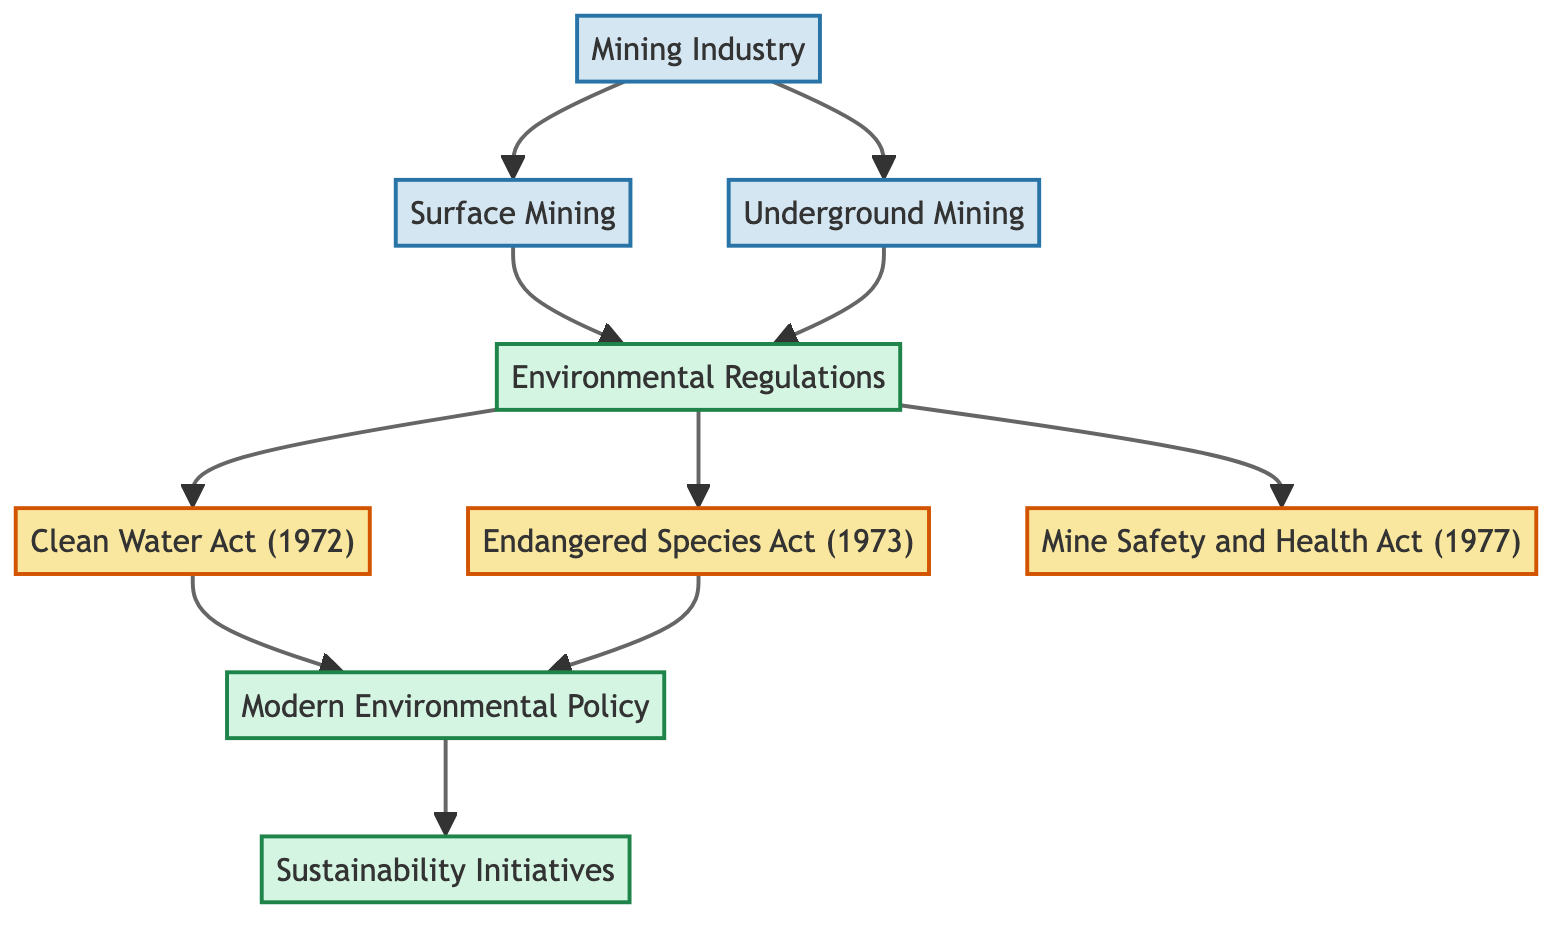What is the total number of nodes in the diagram? The diagram consists of nodes representing key concepts related to mining and environmental policies. Counting them, we have 9 distinct nodes: Mining Industry, Environmental Regulations, Surface Mining, Underground Mining, Clean Water Act, Endangered Species Act, Mining Safety and Health Act, Modern Environmental Policy, and Sustainability Initiatives.
Answer: 9 Which act was established in 1972? According to the diagram, the Clean Water Act is shown to have a direct connection to the Environmental Regulations node and was established in 1972.
Answer: Clean Water Act What connects Surface Mining to Environmental Regulations? The diagram indicates a direct arrow (or edge) from Surface Mining to Environmental Regulations, showing that Surface Mining practices influence or are governed by these regulations.
Answer: Environmental Regulations How many significant acts are directly linked to Environmental Regulations? From the diagram, there are three significant acts connected directly to Environmental Regulations: Clean Water Act, Endangered Species Act, and Mining Safety and Health Act.
Answer: 3 What is the relationship between Modern Environmental Policy and Sustainability Initiatives? The diagram shows a directed edge from Modern Environmental Policy to Sustainability Initiatives, indicating that modern policies lead to or support sustainability efforts in mining.
Answer: Modern Environmental Policy Which two mining practices are connected to the Mining Industry? The diagram shows two arrows emanating from Mining Industry: one leading to Surface Mining and the other to Underground Mining, illustrating the two primary practices under the umbrella of the mining industry.
Answer: Surface Mining, Underground Mining Which act connects most directly to Sustainability Initiatives? The diagram presents a clear connection from Modern Environmental Policy to Sustainability Initiatives, suggesting that sustainability initiatives emerge from or are shaped by contemporary environmental policies.
Answer: Modern Environmental Policy What is the oldest environmental regulation mentioned in the diagram? The Clean Water Act is noted as the first environmental regulation introduced in the diagram, established in 1972, making it the oldest among those represented.
Answer: Clean Water Act How does Underground Mining relate to Environmental Regulations? There is a directed edge from Underground Mining to Environmental Regulations in the diagram, indicating that practices related to Underground Mining fall under or are influenced by these regulations.
Answer: Environmental Regulations 